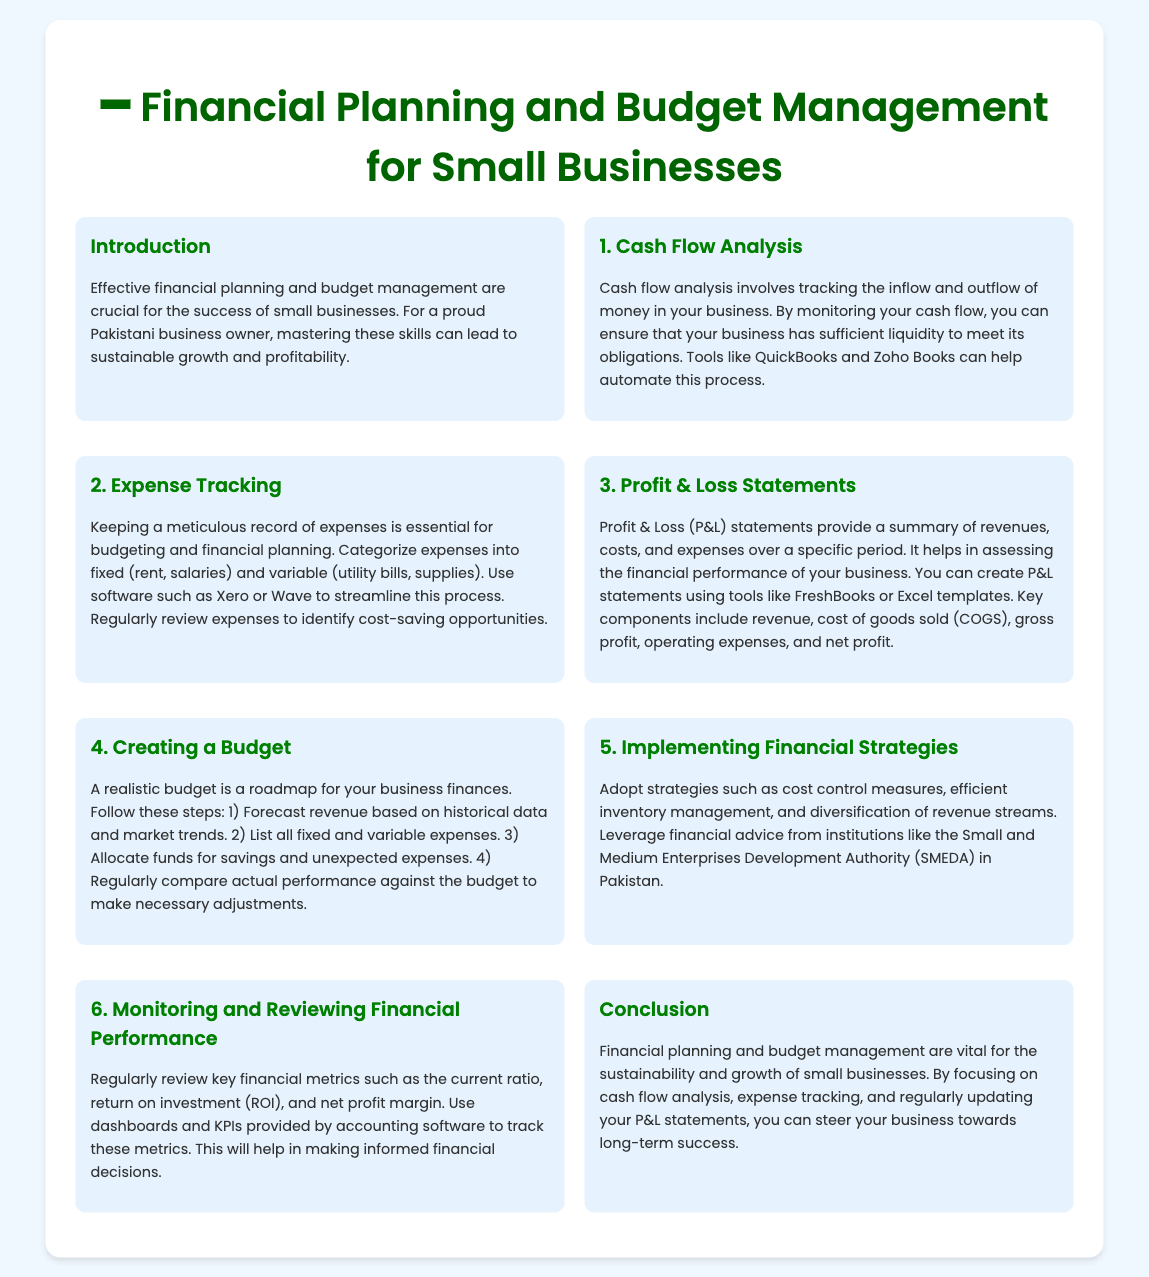What is the main focus of the presentation? The presentation focuses on financial planning and budget management for small businesses.
Answer: financial planning and budget management What can help automate cash flow analysis? QuickBooks and Zoho Books are mentioned as tools that can help automate cash flow analysis.
Answer: QuickBooks and Zoho Books What are the two categories of expenses? The expenses are categorized into fixed and variable.
Answer: fixed and variable What does the P&L statement summarize? The P&L statement summarizes revenues, costs, and expenses over a specific period.
Answer: revenues, costs, and expenses Which organization provides financial advice in Pakistan? The Small and Medium Enterprises Development Authority (SMEDA) offers financial advice in Pakistan.
Answer: SMEDA How often should financial performance be reviewed? Key financial metrics should be reviewed regularly.
Answer: regularly What is a key step in creating a budget? Forecasting revenue based on historical data and market trends is a key step.
Answer: Forecasting revenue What is essential for expense tracking? Keeping a meticulous record of expenses is essential for expense tracking.
Answer: Keeping a meticulous record What is one tool suggested for creating P&L statements? FreshBooks is suggested for creating P&L statements.
Answer: FreshBooks 